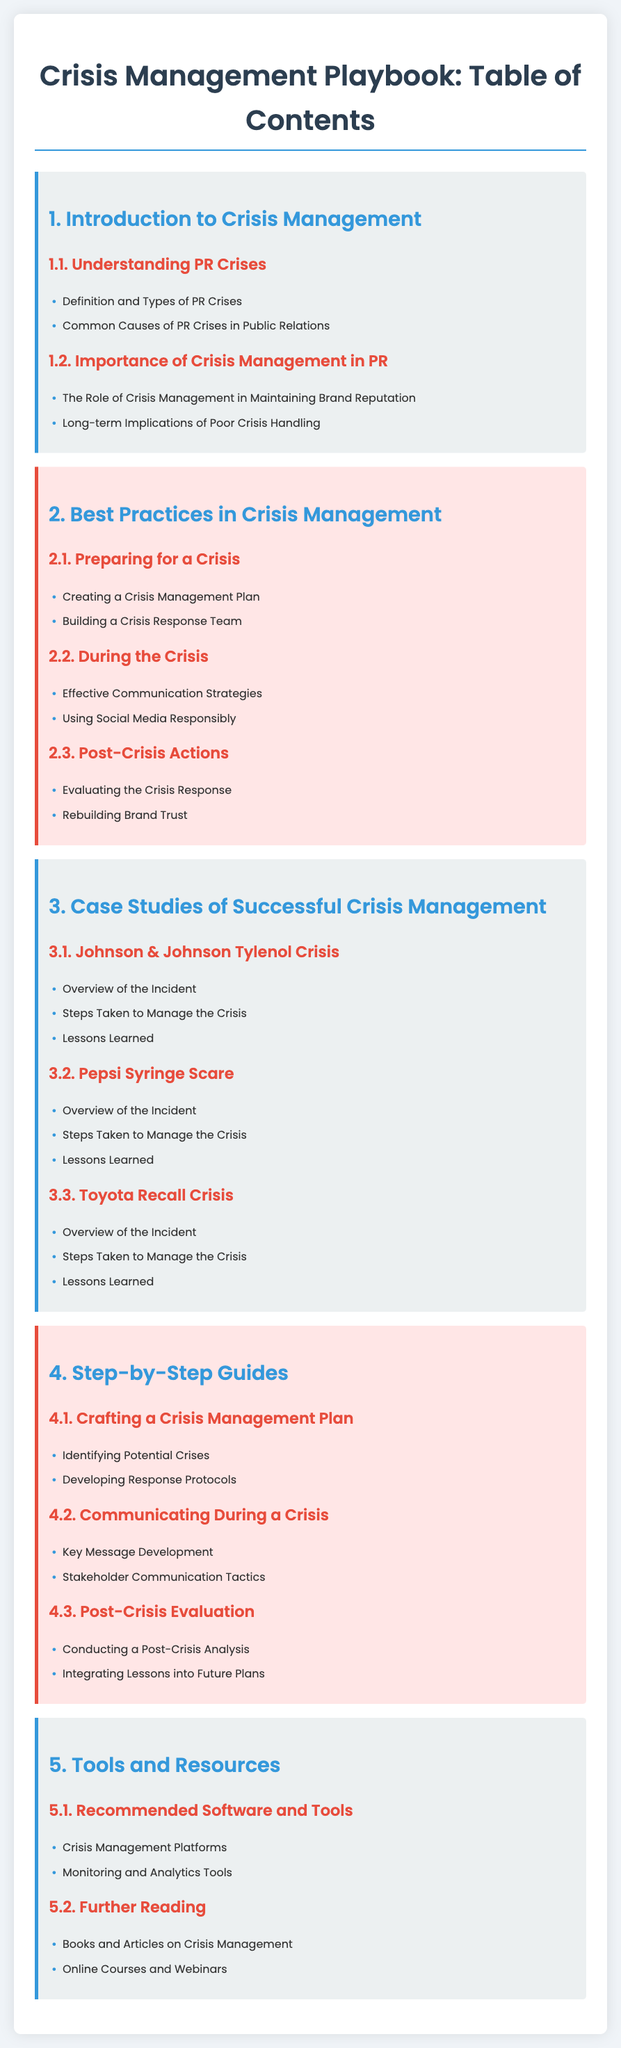What is the first section of the Table of Contents? The first section listed in the Table of Contents is "Introduction to Crisis Management."
Answer: Introduction to Crisis Management How many case studies are mentioned in the document? There are three case studies listed under the "Case Studies of Successful Crisis Management" section.
Answer: 3 Name one best practice in crisis management. A specific recommendation from the best practices section is "Creating a Crisis Management Plan."
Answer: Creating a Crisis Management Plan What does the "Post-Crisis Actions" section focus on? This section focuses on evaluating the crisis response and rebuilding brand trust.
Answer: Evaluating the Crisis Response and Rebuilding Brand Trust Which company is associated with the "Tylenol Crisis"? The company mentioned in this case study is Johnson & Johnson.
Answer: Johnson & Johnson What is one key message development mentioned in the step-by-step guides? The document lists "Key Message Development" as part of the communication strategies during a crisis.
Answer: Key Message Development How many steps are listed in "Post-Crisis Evaluation"? There are two steps in the "Post-Crisis Evaluation" section.
Answer: 2 List one type of tool recommended in the "Tools and Resources" section. The document suggests "Crisis Management Platforms" as a recommended tool.
Answer: Crisis Management Platforms 